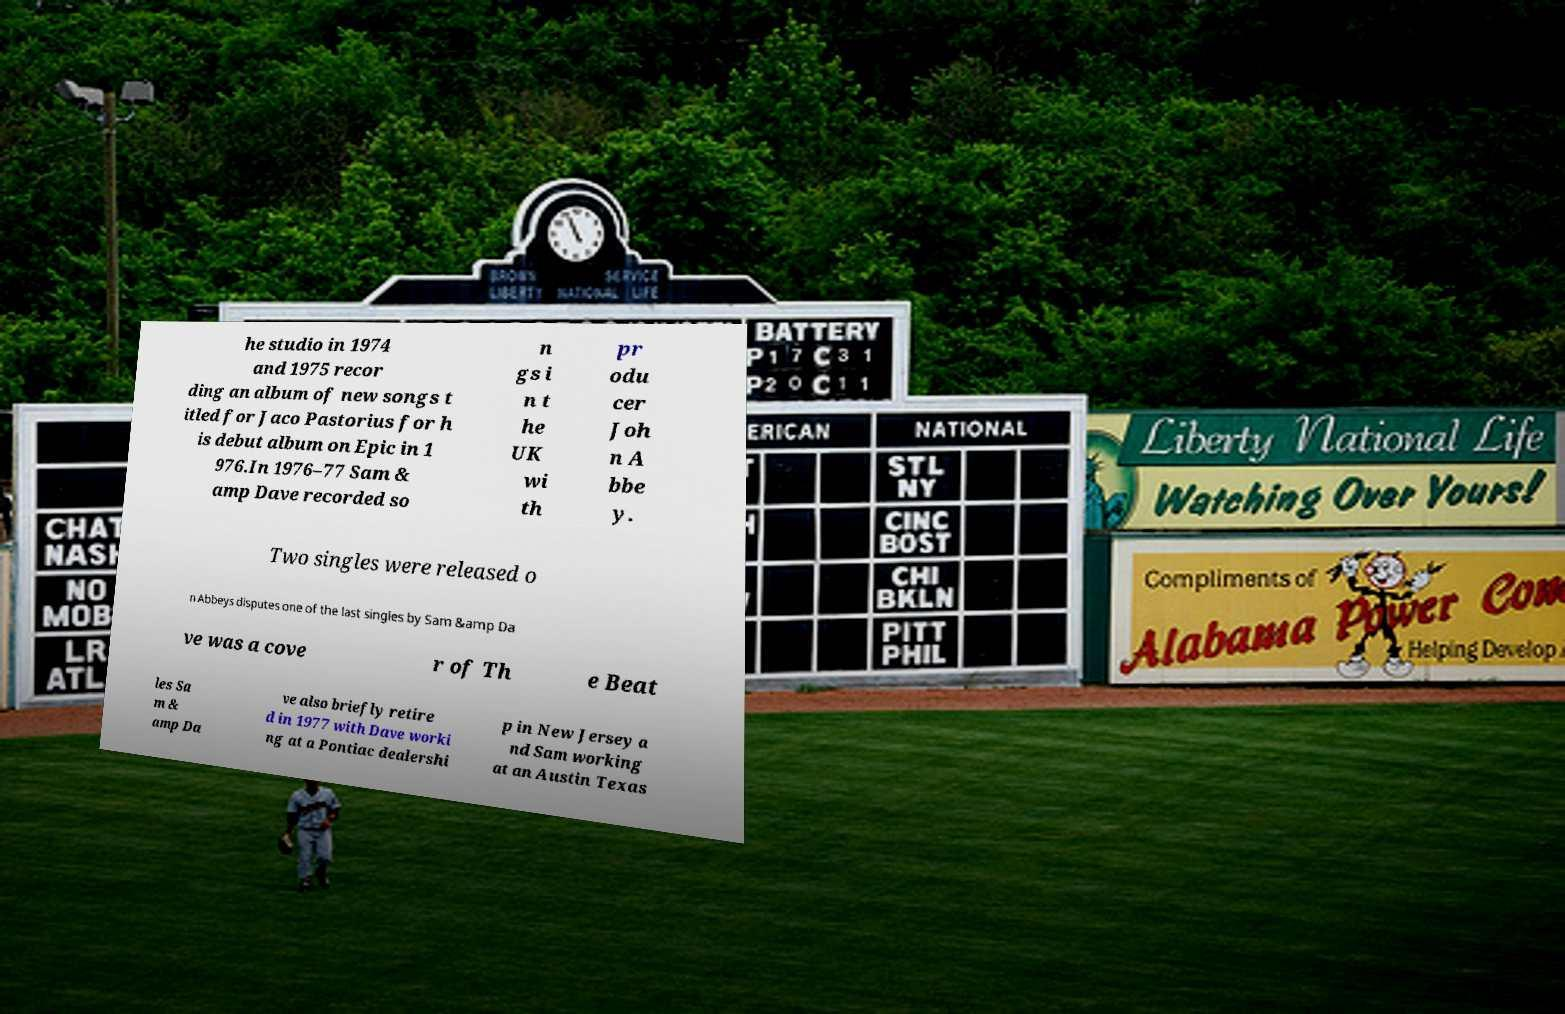What messages or text are displayed in this image? I need them in a readable, typed format. he studio in 1974 and 1975 recor ding an album of new songs t itled for Jaco Pastorius for h is debut album on Epic in 1 976.In 1976–77 Sam & amp Dave recorded so n gs i n t he UK wi th pr odu cer Joh n A bbe y. Two singles were released o n Abbeys disputes one of the last singles by Sam &amp Da ve was a cove r of Th e Beat les Sa m & amp Da ve also briefly retire d in 1977 with Dave worki ng at a Pontiac dealershi p in New Jersey a nd Sam working at an Austin Texas 